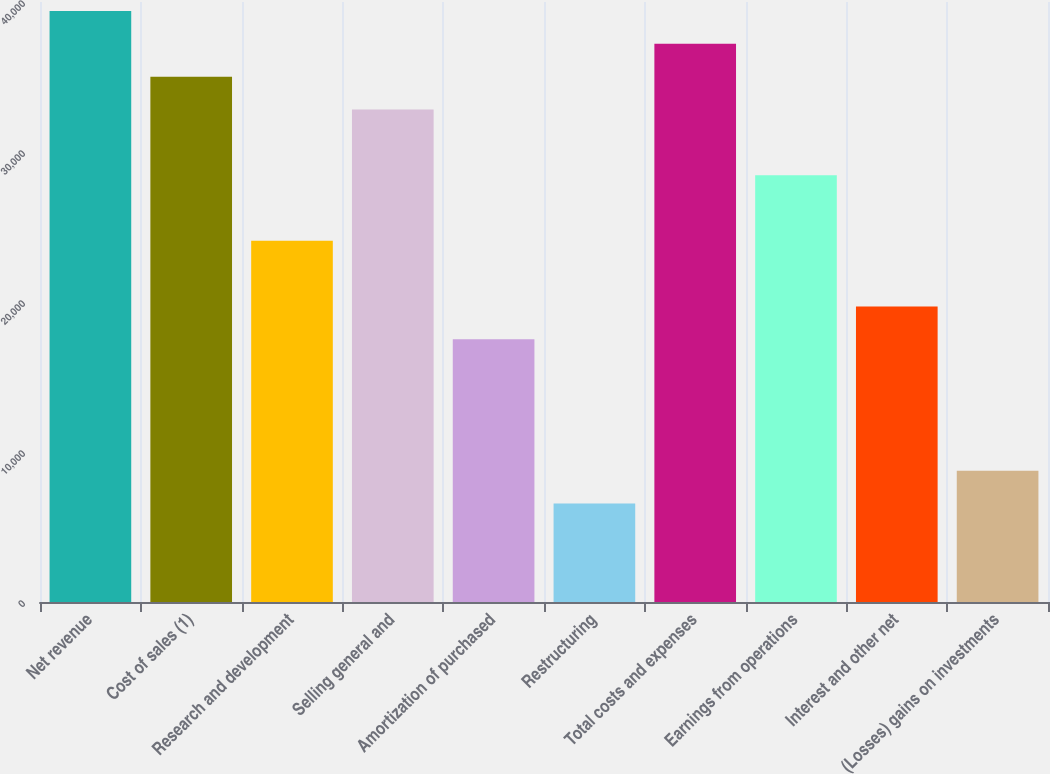Convert chart to OTSL. <chart><loc_0><loc_0><loc_500><loc_500><bar_chart><fcel>Net revenue<fcel>Cost of sales (1)<fcel>Research and development<fcel>Selling general and<fcel>Amortization of purchased<fcel>Restructuring<fcel>Total costs and expenses<fcel>Earnings from operations<fcel>Interest and other net<fcel>(Losses) gains on investments<nl><fcel>39401.9<fcel>35023.9<fcel>24079<fcel>32834.9<fcel>17512<fcel>6567.05<fcel>37212.9<fcel>28457<fcel>19701<fcel>8756.04<nl></chart> 